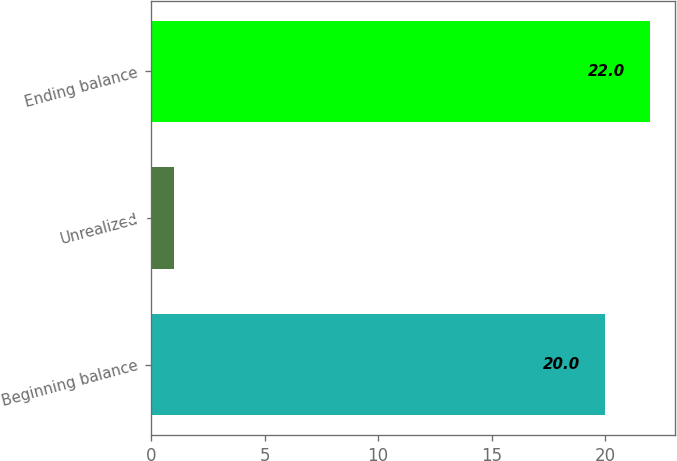Convert chart to OTSL. <chart><loc_0><loc_0><loc_500><loc_500><bar_chart><fcel>Beginning balance<fcel>Unrealized<fcel>Ending balance<nl><fcel>20<fcel>1<fcel>22<nl></chart> 